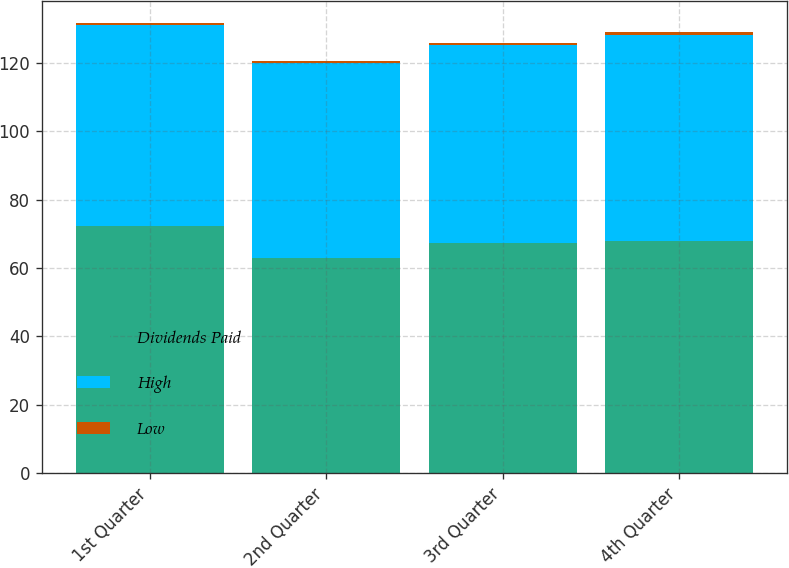Convert chart to OTSL. <chart><loc_0><loc_0><loc_500><loc_500><stacked_bar_chart><ecel><fcel>1st Quarter<fcel>2nd Quarter<fcel>3rd Quarter<fcel>4th Quarter<nl><fcel>Dividends Paid<fcel>72.25<fcel>63.03<fcel>67.37<fcel>67.94<nl><fcel>High<fcel>58.65<fcel>56.86<fcel>57.71<fcel>60.3<nl><fcel>Low<fcel>0.65<fcel>0.65<fcel>0.65<fcel>0.65<nl></chart> 